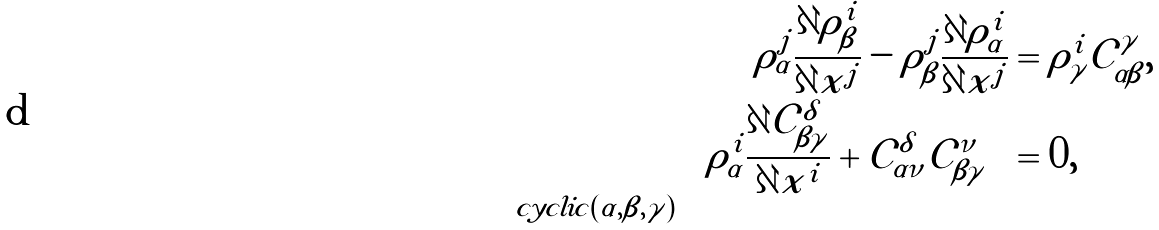Convert formula to latex. <formula><loc_0><loc_0><loc_500><loc_500>\rho _ { \alpha } ^ { j } \frac { \partial \rho _ { \beta } ^ { i } } { \partial x ^ { j } } - \rho _ { \beta } ^ { j } \frac { \partial \rho _ { \alpha } ^ { i } } { \partial x ^ { j } } & = \rho _ { \gamma } ^ { i } { \mathcal { C } } _ { \alpha \beta } ^ { \gamma } , \\ \sum _ { c y c l i c ( \alpha , \beta , \gamma ) } \left ( \rho _ { \alpha } ^ { i } \frac { \partial { \mathcal { C } } _ { \beta \gamma } ^ { \delta } } { \partial x ^ { i } } + { \mathcal { C } } _ { \alpha \nu } ^ { \delta } { \mathcal { C } } _ { \beta \gamma } ^ { \nu } \right ) & = 0 ,</formula> 